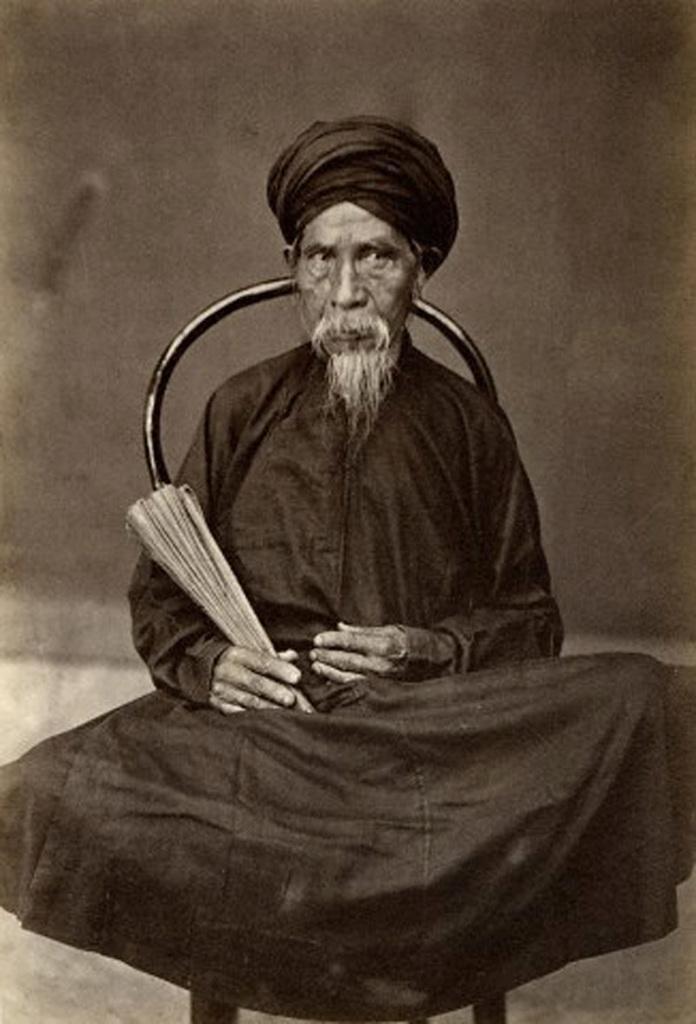Could you give a brief overview of what you see in this image? In this image there is an old photograph of a person sitting in a chair. 